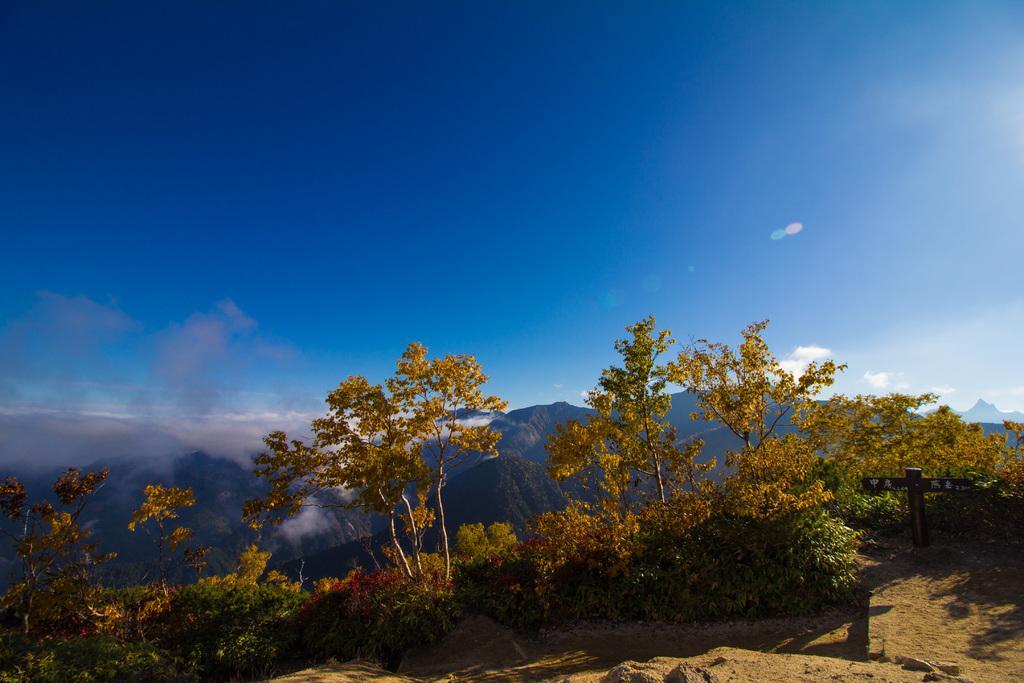Can you describe this image briefly? These are the trees and small bushes. This looks like a board attached to a pole. In the background, I can see the mountains. This is the sky. 